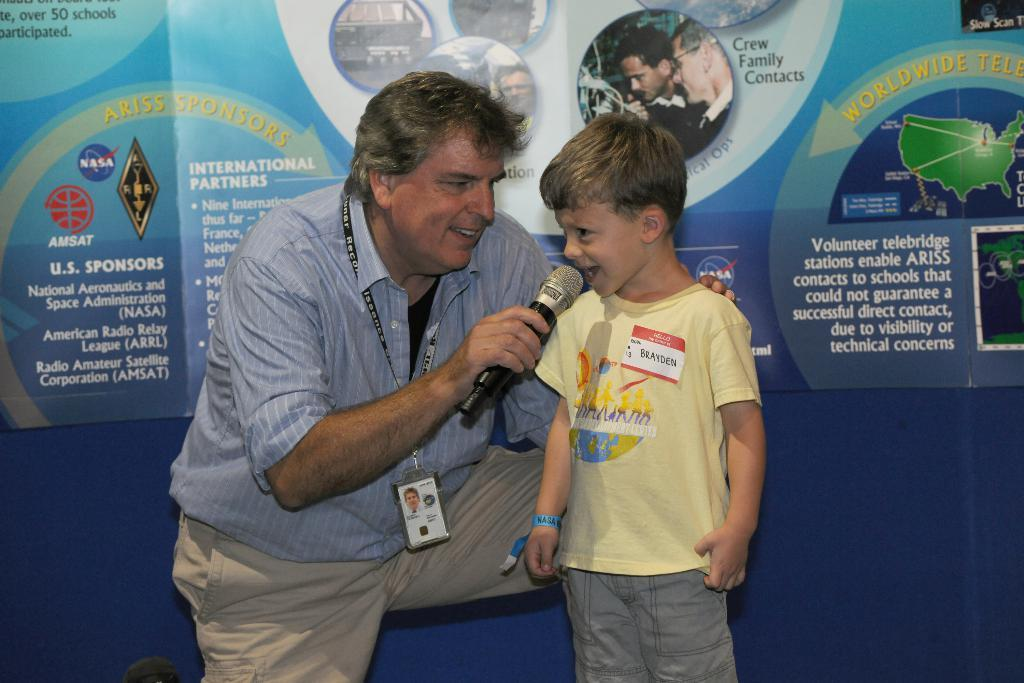What is the person in the image holding? The person is holding a microphone in the image. Who is the person holding the microphone interacting with? The person is holding the microphone in front of a boy. What can be seen in the background of the image? There is a poster visible in the background of the image. What features does the poster have? The poster has text and pictures on it. Can you tell me how many knots are tied on the microphone in the image? There are no knots present on the microphone in the image. What type of offer is being made by the person holding the microphone? There is no offer being made in the image; the person is simply holding a microphone in front of a boy. 